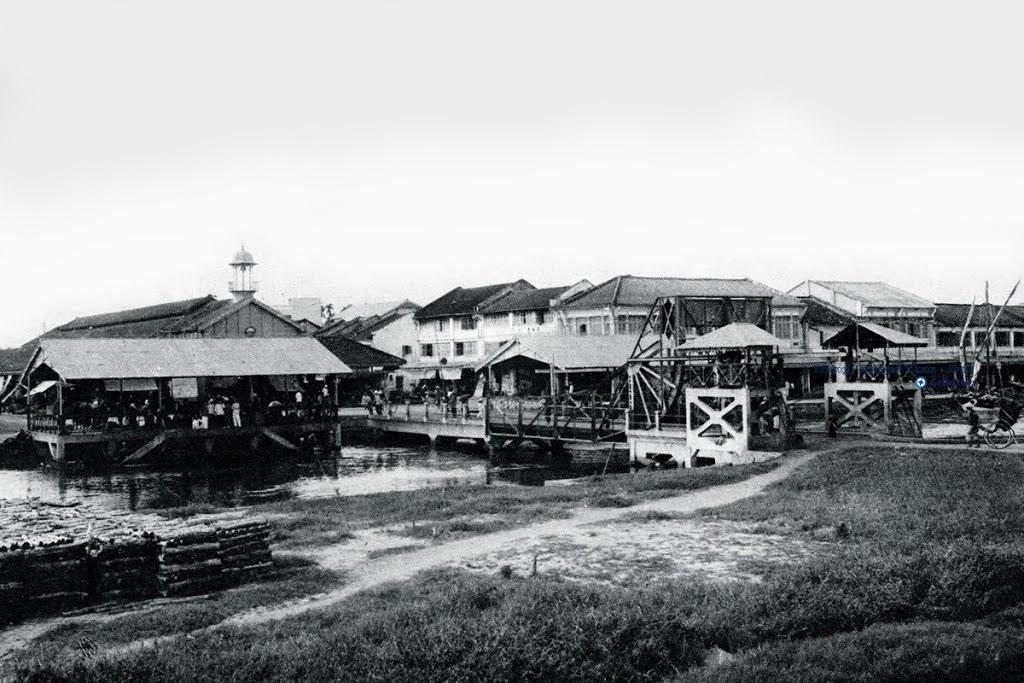What type of vegetation is present on the right side of the image? There is grass on the ground on the right side of the image. What structures can be seen in the background of the image? There are buildings with roofs in the background of the image. What natural element is visible in the background of the image? There is water visible in the background of the image. What can be seen in the sky in the background of the image? There are clouds in the sky in the background of the image. What type of celery is growing on the canvas in the image? There is no celery or canvas present in the image. How many beans are visible on the ground in the image? There are no beans visible on the ground in the image. 